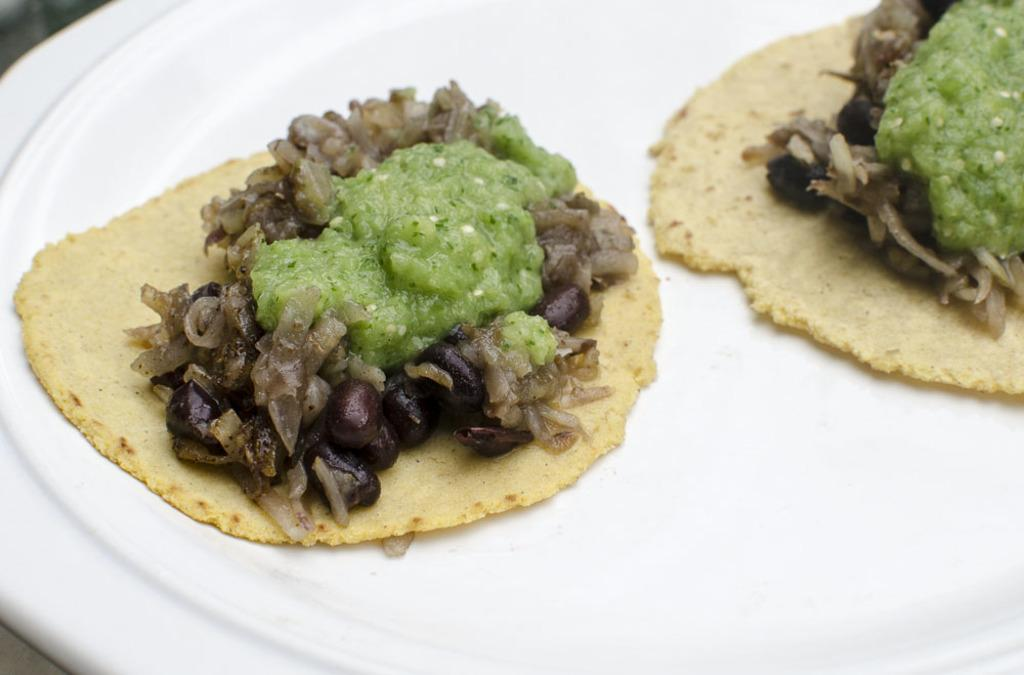What is on the plate that is visible in the image? There is food on a plate in the image. What color is the plate? The plate is white. Can you tell me how many scarecrows are present in the image? There are no scarecrows present in the image; it only features a plate of food on a white plate. What type of vegetable is being served on the plate in the image? The facts provided do not specify the type of food on the plate, so it cannot be determined if it is a vegetable or not. 